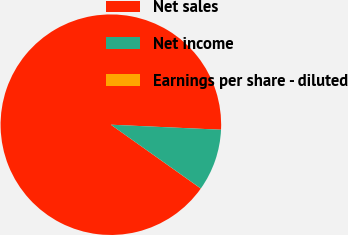Convert chart to OTSL. <chart><loc_0><loc_0><loc_500><loc_500><pie_chart><fcel>Net sales<fcel>Net income<fcel>Earnings per share - diluted<nl><fcel>90.9%<fcel>9.09%<fcel>0.01%<nl></chart> 